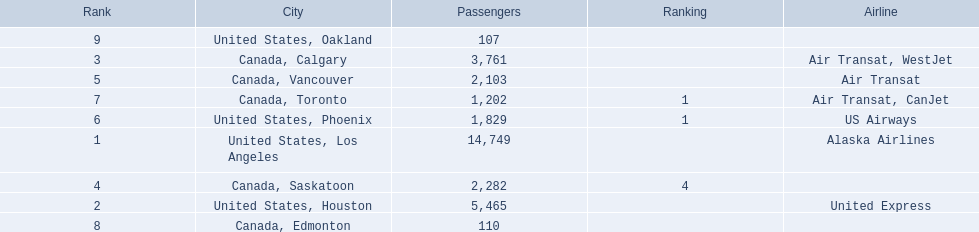Where are the destinations of the airport? United States, Los Angeles, United States, Houston, Canada, Calgary, Canada, Saskatoon, Canada, Vancouver, United States, Phoenix, Canada, Toronto, Canada, Edmonton, United States, Oakland. What is the number of passengers to phoenix? 1,829. 